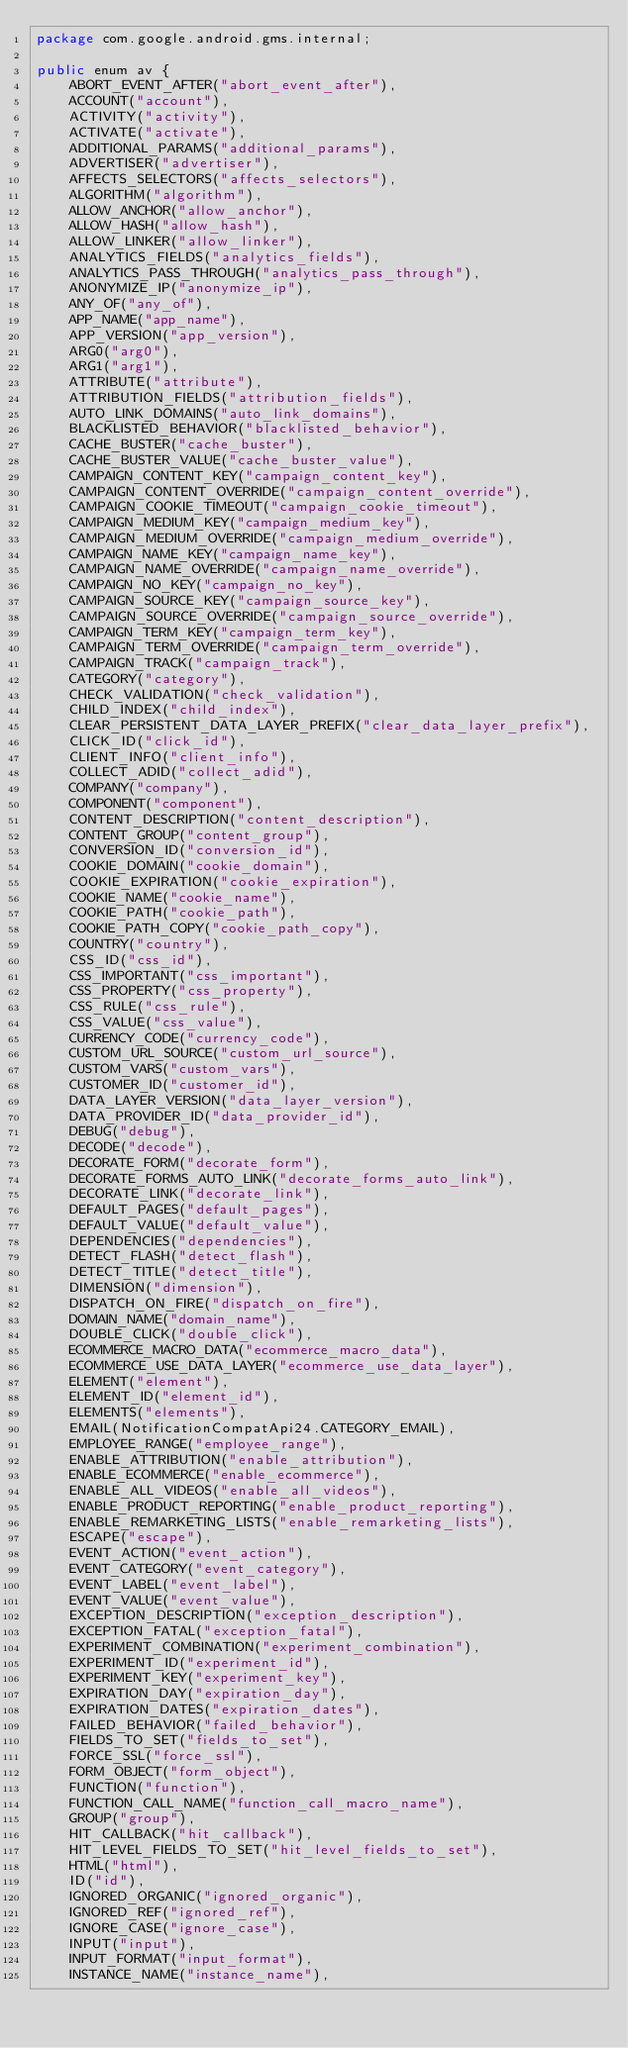Convert code to text. <code><loc_0><loc_0><loc_500><loc_500><_Java_>package com.google.android.gms.internal;

public enum av {
    ABORT_EVENT_AFTER("abort_event_after"),
    ACCOUNT("account"),
    ACTIVITY("activity"),
    ACTIVATE("activate"),
    ADDITIONAL_PARAMS("additional_params"),
    ADVERTISER("advertiser"),
    AFFECTS_SELECTORS("affects_selectors"),
    ALGORITHM("algorithm"),
    ALLOW_ANCHOR("allow_anchor"),
    ALLOW_HASH("allow_hash"),
    ALLOW_LINKER("allow_linker"),
    ANALYTICS_FIELDS("analytics_fields"),
    ANALYTICS_PASS_THROUGH("analytics_pass_through"),
    ANONYMIZE_IP("anonymize_ip"),
    ANY_OF("any_of"),
    APP_NAME("app_name"),
    APP_VERSION("app_version"),
    ARG0("arg0"),
    ARG1("arg1"),
    ATTRIBUTE("attribute"),
    ATTRIBUTION_FIELDS("attribution_fields"),
    AUTO_LINK_DOMAINS("auto_link_domains"),
    BLACKLISTED_BEHAVIOR("blacklisted_behavior"),
    CACHE_BUSTER("cache_buster"),
    CACHE_BUSTER_VALUE("cache_buster_value"),
    CAMPAIGN_CONTENT_KEY("campaign_content_key"),
    CAMPAIGN_CONTENT_OVERRIDE("campaign_content_override"),
    CAMPAIGN_COOKIE_TIMEOUT("campaign_cookie_timeout"),
    CAMPAIGN_MEDIUM_KEY("campaign_medium_key"),
    CAMPAIGN_MEDIUM_OVERRIDE("campaign_medium_override"),
    CAMPAIGN_NAME_KEY("campaign_name_key"),
    CAMPAIGN_NAME_OVERRIDE("campaign_name_override"),
    CAMPAIGN_NO_KEY("campaign_no_key"),
    CAMPAIGN_SOURCE_KEY("campaign_source_key"),
    CAMPAIGN_SOURCE_OVERRIDE("campaign_source_override"),
    CAMPAIGN_TERM_KEY("campaign_term_key"),
    CAMPAIGN_TERM_OVERRIDE("campaign_term_override"),
    CAMPAIGN_TRACK("campaign_track"),
    CATEGORY("category"),
    CHECK_VALIDATION("check_validation"),
    CHILD_INDEX("child_index"),
    CLEAR_PERSISTENT_DATA_LAYER_PREFIX("clear_data_layer_prefix"),
    CLICK_ID("click_id"),
    CLIENT_INFO("client_info"),
    COLLECT_ADID("collect_adid"),
    COMPANY("company"),
    COMPONENT("component"),
    CONTENT_DESCRIPTION("content_description"),
    CONTENT_GROUP("content_group"),
    CONVERSION_ID("conversion_id"),
    COOKIE_DOMAIN("cookie_domain"),
    COOKIE_EXPIRATION("cookie_expiration"),
    COOKIE_NAME("cookie_name"),
    COOKIE_PATH("cookie_path"),
    COOKIE_PATH_COPY("cookie_path_copy"),
    COUNTRY("country"),
    CSS_ID("css_id"),
    CSS_IMPORTANT("css_important"),
    CSS_PROPERTY("css_property"),
    CSS_RULE("css_rule"),
    CSS_VALUE("css_value"),
    CURRENCY_CODE("currency_code"),
    CUSTOM_URL_SOURCE("custom_url_source"),
    CUSTOM_VARS("custom_vars"),
    CUSTOMER_ID("customer_id"),
    DATA_LAYER_VERSION("data_layer_version"),
    DATA_PROVIDER_ID("data_provider_id"),
    DEBUG("debug"),
    DECODE("decode"),
    DECORATE_FORM("decorate_form"),
    DECORATE_FORMS_AUTO_LINK("decorate_forms_auto_link"),
    DECORATE_LINK("decorate_link"),
    DEFAULT_PAGES("default_pages"),
    DEFAULT_VALUE("default_value"),
    DEPENDENCIES("dependencies"),
    DETECT_FLASH("detect_flash"),
    DETECT_TITLE("detect_title"),
    DIMENSION("dimension"),
    DISPATCH_ON_FIRE("dispatch_on_fire"),
    DOMAIN_NAME("domain_name"),
    DOUBLE_CLICK("double_click"),
    ECOMMERCE_MACRO_DATA("ecommerce_macro_data"),
    ECOMMERCE_USE_DATA_LAYER("ecommerce_use_data_layer"),
    ELEMENT("element"),
    ELEMENT_ID("element_id"),
    ELEMENTS("elements"),
    EMAIL(NotificationCompatApi24.CATEGORY_EMAIL),
    EMPLOYEE_RANGE("employee_range"),
    ENABLE_ATTRIBUTION("enable_attribution"),
    ENABLE_ECOMMERCE("enable_ecommerce"),
    ENABLE_ALL_VIDEOS("enable_all_videos"),
    ENABLE_PRODUCT_REPORTING("enable_product_reporting"),
    ENABLE_REMARKETING_LISTS("enable_remarketing_lists"),
    ESCAPE("escape"),
    EVENT_ACTION("event_action"),
    EVENT_CATEGORY("event_category"),
    EVENT_LABEL("event_label"),
    EVENT_VALUE("event_value"),
    EXCEPTION_DESCRIPTION("exception_description"),
    EXCEPTION_FATAL("exception_fatal"),
    EXPERIMENT_COMBINATION("experiment_combination"),
    EXPERIMENT_ID("experiment_id"),
    EXPERIMENT_KEY("experiment_key"),
    EXPIRATION_DAY("expiration_day"),
    EXPIRATION_DATES("expiration_dates"),
    FAILED_BEHAVIOR("failed_behavior"),
    FIELDS_TO_SET("fields_to_set"),
    FORCE_SSL("force_ssl"),
    FORM_OBJECT("form_object"),
    FUNCTION("function"),
    FUNCTION_CALL_NAME("function_call_macro_name"),
    GROUP("group"),
    HIT_CALLBACK("hit_callback"),
    HIT_LEVEL_FIELDS_TO_SET("hit_level_fields_to_set"),
    HTML("html"),
    ID("id"),
    IGNORED_ORGANIC("ignored_organic"),
    IGNORED_REF("ignored_ref"),
    IGNORE_CASE("ignore_case"),
    INPUT("input"),
    INPUT_FORMAT("input_format"),
    INSTANCE_NAME("instance_name"),</code> 